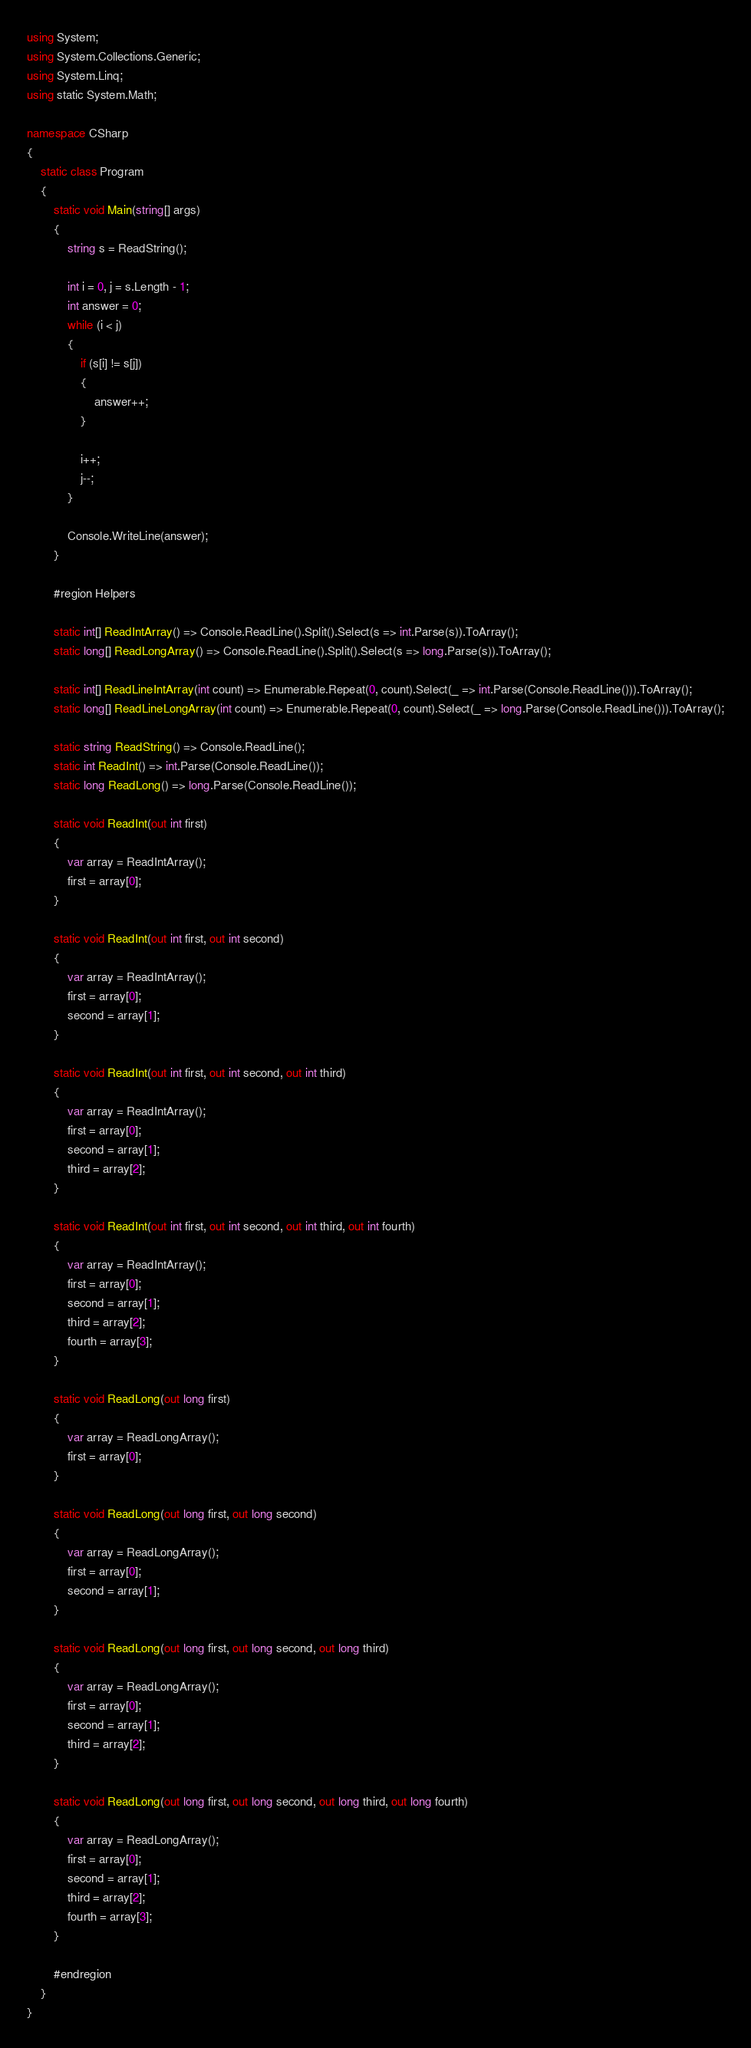Convert code to text. <code><loc_0><loc_0><loc_500><loc_500><_C#_>using System;
using System.Collections.Generic;
using System.Linq;
using static System.Math;

namespace CSharp
{
    static class Program
    {
        static void Main(string[] args)
        {
            string s = ReadString();

            int i = 0, j = s.Length - 1;
            int answer = 0;
            while (i < j)
            {
                if (s[i] != s[j])
                {
                    answer++;
                }

                i++;
                j--;
            }

            Console.WriteLine(answer);
        }

        #region Helpers

        static int[] ReadIntArray() => Console.ReadLine().Split().Select(s => int.Parse(s)).ToArray();
        static long[] ReadLongArray() => Console.ReadLine().Split().Select(s => long.Parse(s)).ToArray();

        static int[] ReadLineIntArray(int count) => Enumerable.Repeat(0, count).Select(_ => int.Parse(Console.ReadLine())).ToArray();
        static long[] ReadLineLongArray(int count) => Enumerable.Repeat(0, count).Select(_ => long.Parse(Console.ReadLine())).ToArray();

        static string ReadString() => Console.ReadLine();
        static int ReadInt() => int.Parse(Console.ReadLine());
        static long ReadLong() => long.Parse(Console.ReadLine());

        static void ReadInt(out int first)
        {
            var array = ReadIntArray();
            first = array[0];
        }

        static void ReadInt(out int first, out int second)
        {
            var array = ReadIntArray();
            first = array[0];
            second = array[1];
        }

        static void ReadInt(out int first, out int second, out int third)
        {
            var array = ReadIntArray();
            first = array[0];
            second = array[1];
            third = array[2];
        }

        static void ReadInt(out int first, out int second, out int third, out int fourth)
        {
            var array = ReadIntArray();
            first = array[0];
            second = array[1];
            third = array[2];
            fourth = array[3];
        }

        static void ReadLong(out long first)
        {
            var array = ReadLongArray();
            first = array[0];
        }

        static void ReadLong(out long first, out long second)
        {
            var array = ReadLongArray();
            first = array[0];
            second = array[1];
        }

        static void ReadLong(out long first, out long second, out long third)
        {
            var array = ReadLongArray();
            first = array[0];
            second = array[1];
            third = array[2];
        }

        static void ReadLong(out long first, out long second, out long third, out long fourth)
        {
            var array = ReadLongArray();
            first = array[0];
            second = array[1];
            third = array[2];
            fourth = array[3];
        }

        #endregion
    }
}</code> 